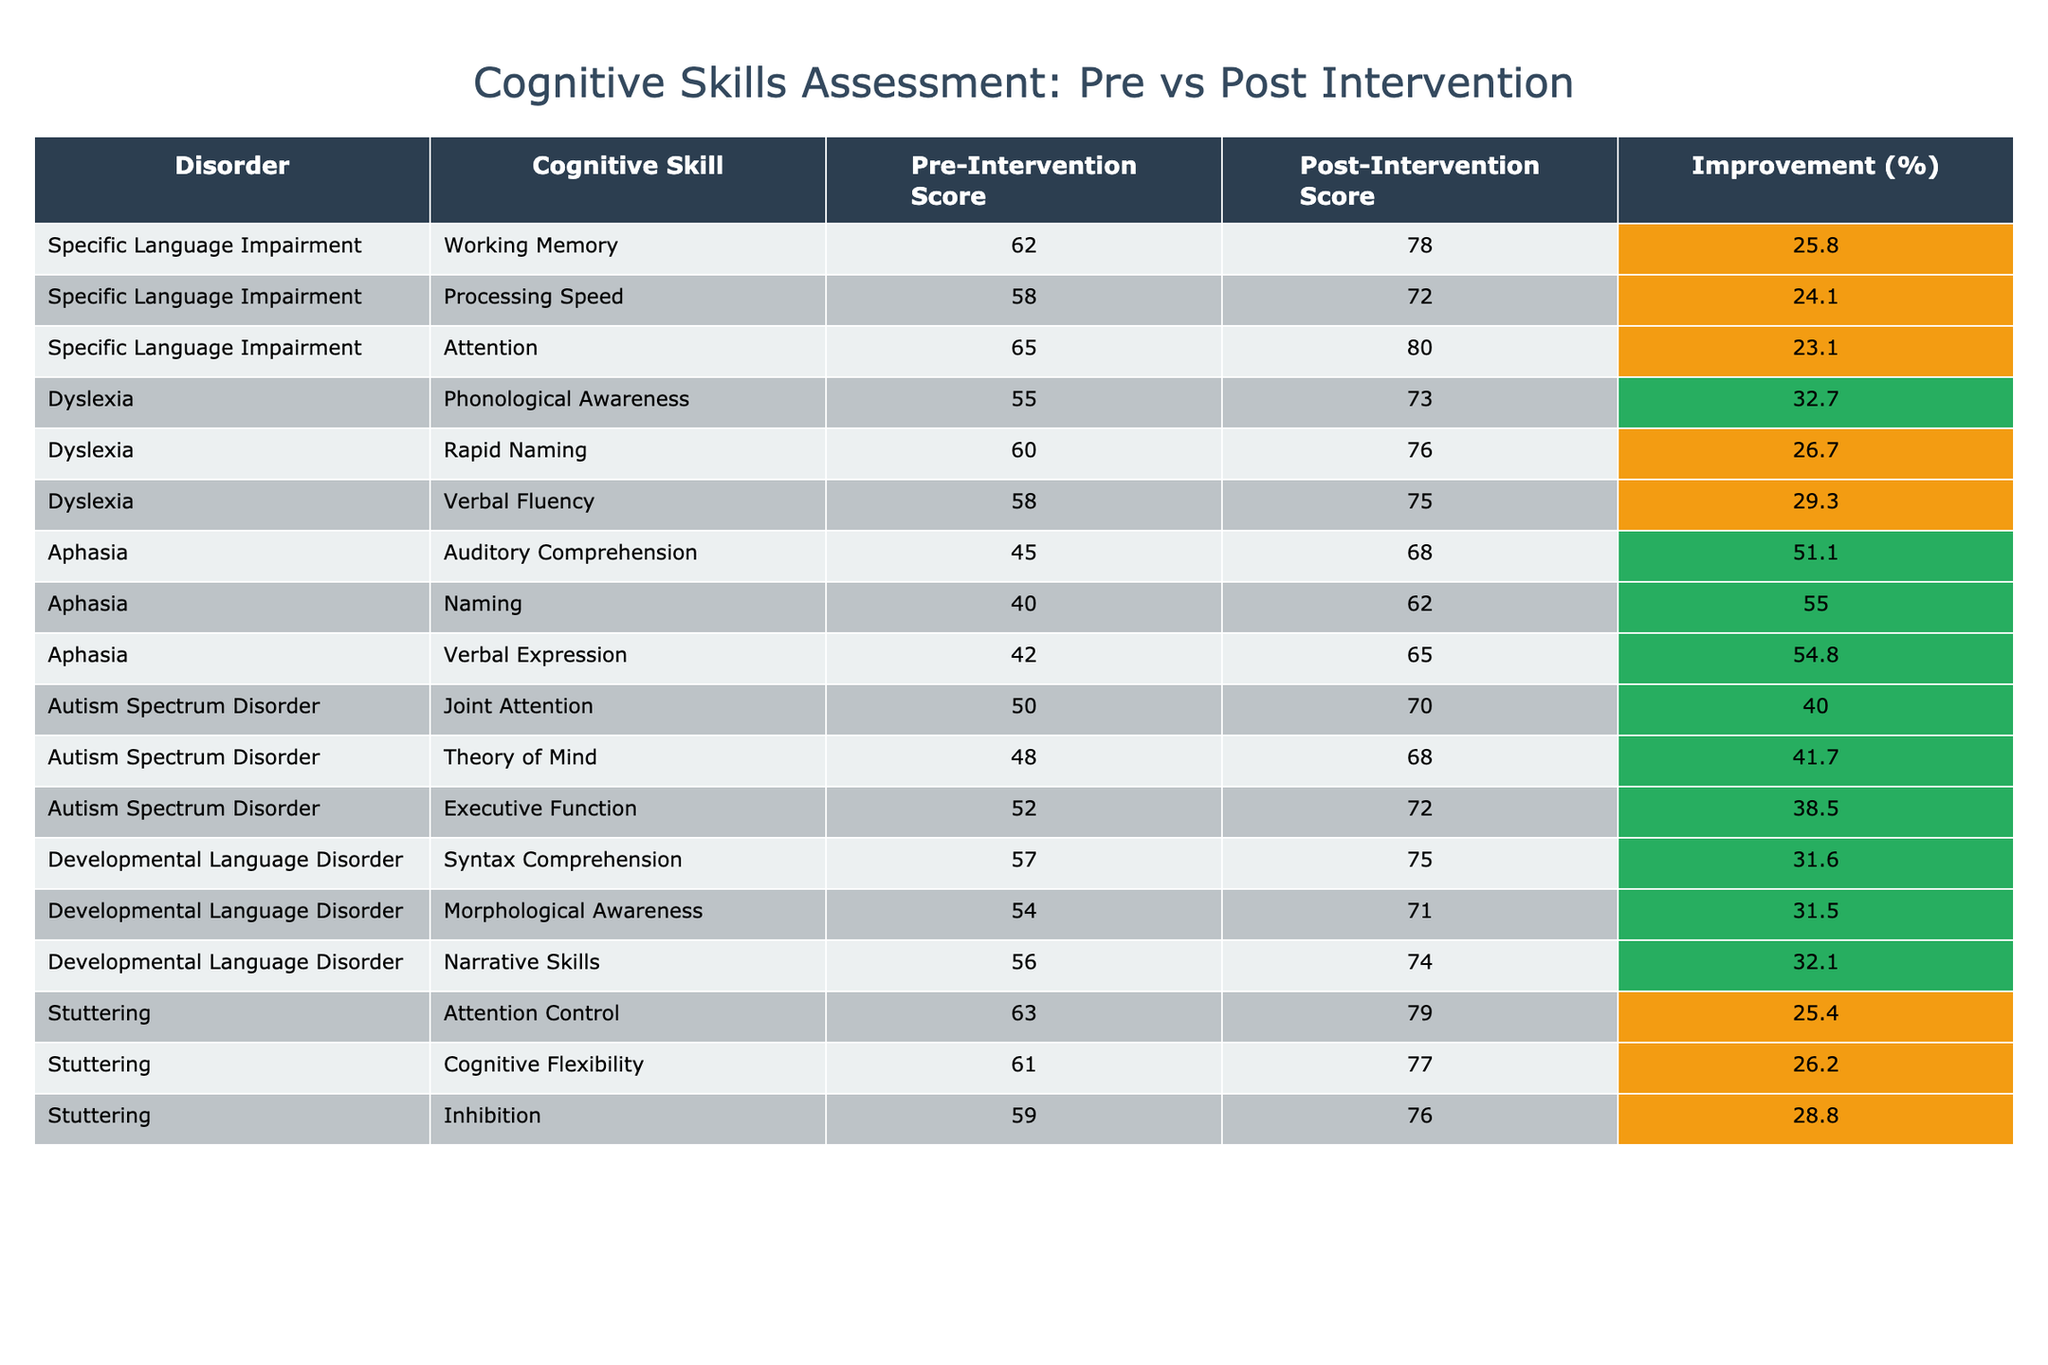What is the pre-intervention score for Working Memory in Specific Language Impairment? The table clearly states that the pre-intervention score for Working Memory under Specific Language Impairment is 62.
Answer: 62 What is the post-intervention score for Phonological Awareness in Dyslexia? The table indicates that the post-intervention score for Phonological Awareness in Dyslexia is 73.
Answer: 73 Which cognitive skill in Stuttering showed the highest improvement percentage? The improvement percentages are calculated as follows: Attention Control improved from 63 to 79 (25.4%), Cognitive Flexibility from 61 to 77 (26.2%), and Inhibition from 59 to 76 (28.8%). The highest improvement is in Inhibition with 28.8%.
Answer: Inhibition Is the post-intervention score for Joint Attention in Autism Spectrum Disorder higher than 65? According to the table, the post-intervention score for Joint Attention in Autism Spectrum Disorder is 70, which is indeed higher than 65.
Answer: Yes What is the average pre-intervention score across all cognitive skills for Developmental Language Disorder? The pre-intervention scores for Developmental Language Disorder are 57, 54, and 56. Calculating the average gives (57 + 54 + 56) / 3 = 55.67.
Answer: 55.67 How much did the post-intervention score increase for Verbal Expression in Aphasia? The pre-intervention score for Verbal Expression is 42, and the post-intervention score is 65. The increase is 65 - 42 = 23.
Answer: 23 Which language disorder had the lowest pre-intervention score for any cognitive skill? Reviewing the table, Aphasia has the lowest pre-intervention score for Auditory Comprehension at 45, which is the lowest value among all the scores listed.
Answer: Aphasia What is the total improvement in score for Syntax Comprehension in Developmental Language Disorder? The pre-intervention score for Syntax Comprehension is 57, and the post-intervention score is 75. The total improvement is calculated as 75 - 57 = 18.
Answer: 18 Which disorder had the highest overall average pre-intervention score? Calculating the average pre-intervention scores: Specific Language Impairment = (62 + 58 + 65) / 3 = 61, Dyslexia = (55 + 60 + 58) / 3 = 57.67, Aphasia = (45 + 40 + 42) / 3 = 42.33, Autism Spectrum Disorder = (50 + 48 + 52) / 3 = 50, Developmental Language Disorder = (57 + 54 + 56) / 3 = 55.67, Stuttering = (63 + 61 + 59) / 3 = 61.33. The highest average is Specific Language Impairment at 61.
Answer: Specific Language Impairment 